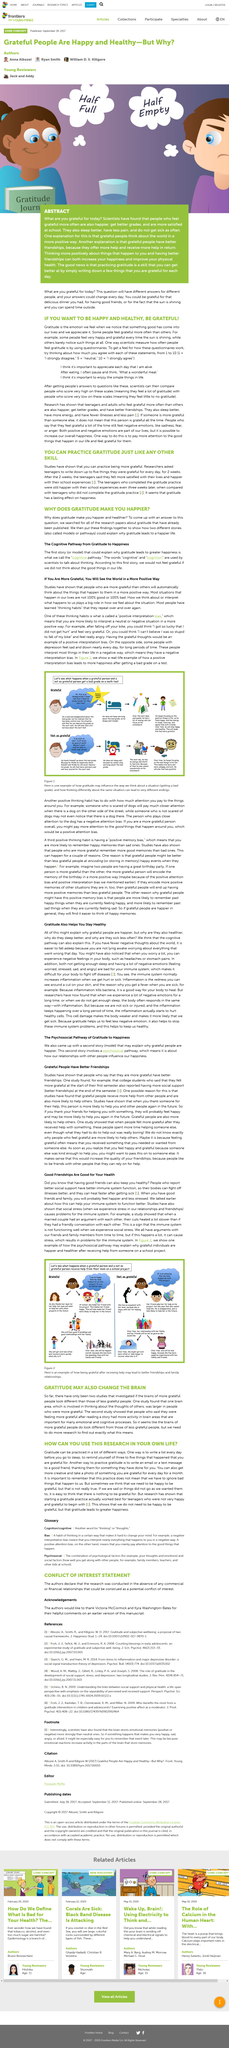Highlight a few significant elements in this photo. It is possible for scientists to study gratitude by using questionnaires. Yes, it does seem that the brains of more grateful people differ from those of less grateful people. Gratitude, as measured by scientists, has been found to be a significant contributor to happiness and healthiness. Gratitude can be practiced just like any other skill. The teenagers wrote for two weeks about what they were grateful for every day. 